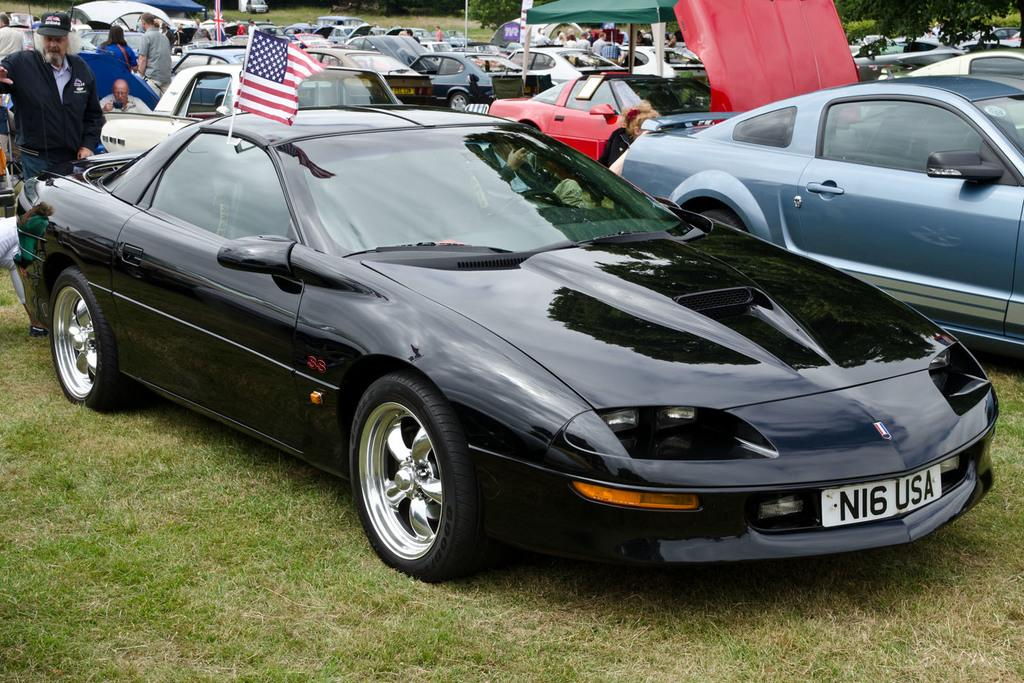What can be seen in the middle of the image? There are cars parked in the parking lot in the middle of the image. What is located on the left side of the image? There are people on the left side of the image. What type of ground surface is visible in the image? There is grass on the ground in the image. Can you see any bees buzzing around the grass in the image? There is no mention of bees in the image, so we cannot determine if they are present or not. How many sheep are grazing on the grass in the image? There is no mention of sheep in the image, so we cannot determine if they are present or not. 